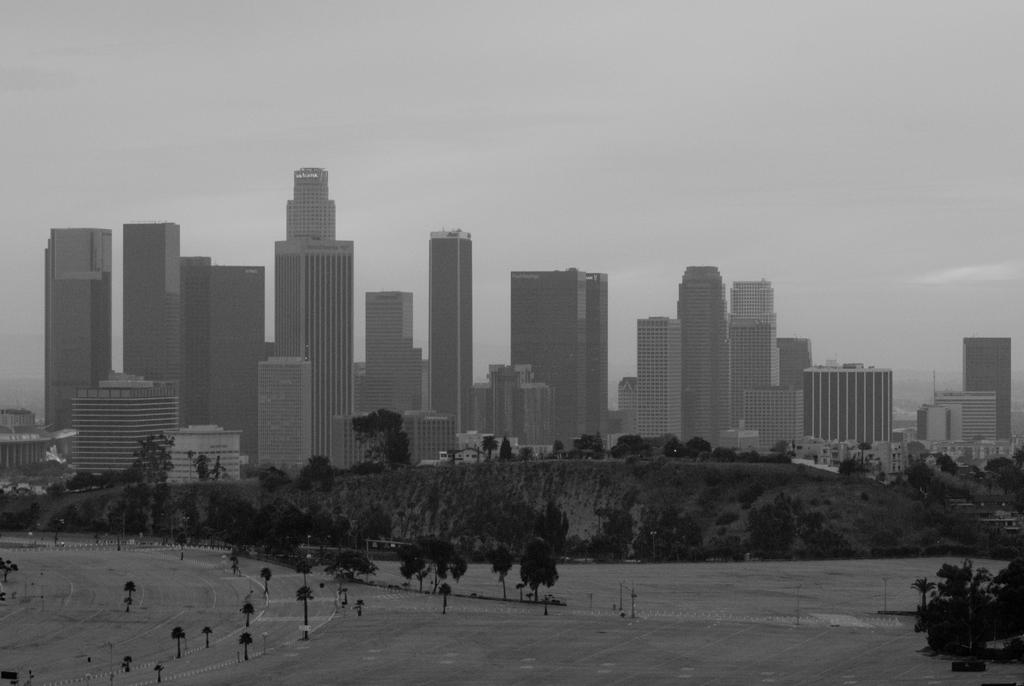What type of natural vegetation is present in the image? There are trees in the image. What type of geographical feature can be seen in the image? There are mountains in the image. What type of man-made structures are visible in the image? There are buildings in the image. Where is the playground located in the image? There is no playground present in the image. What type of bath can be seen in the image? There is no bath present in the image. 